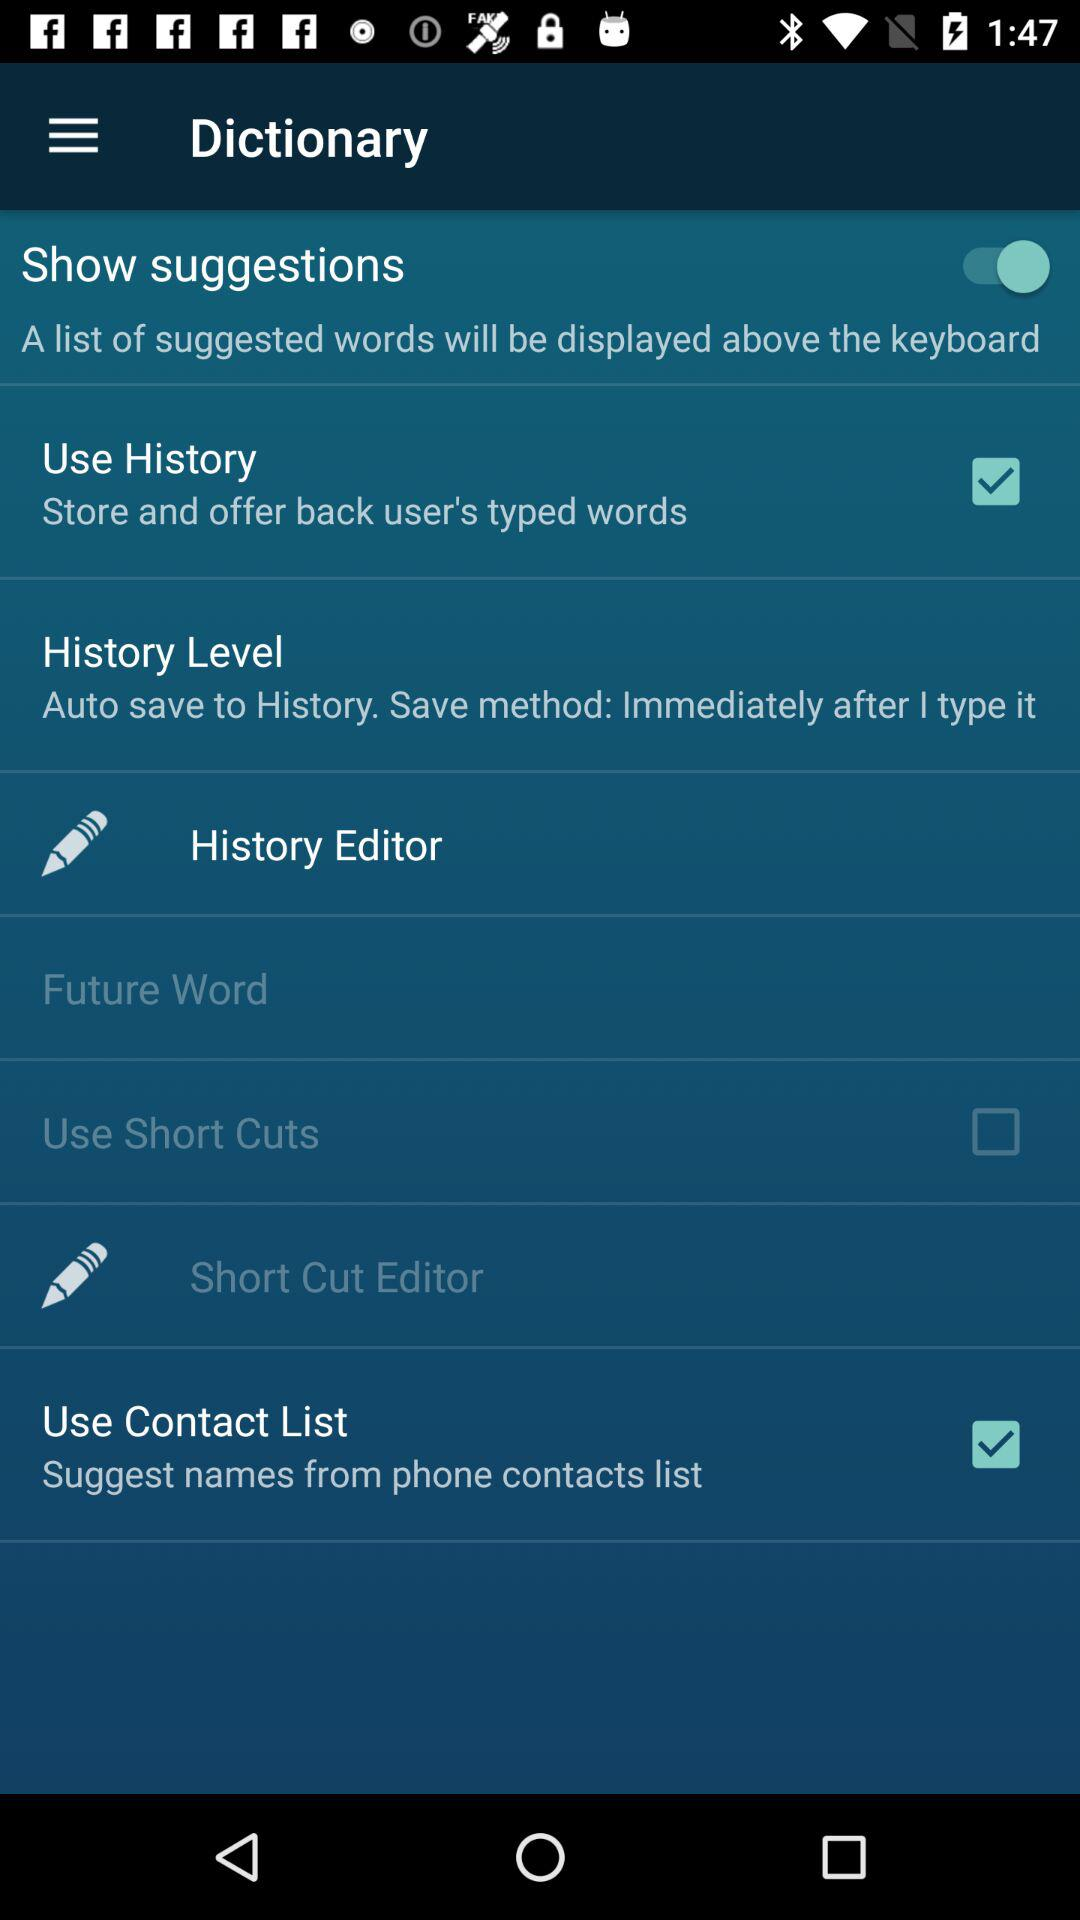What is the current status of "Use Contact List"? The current status of "Use Contact List" is "on". 